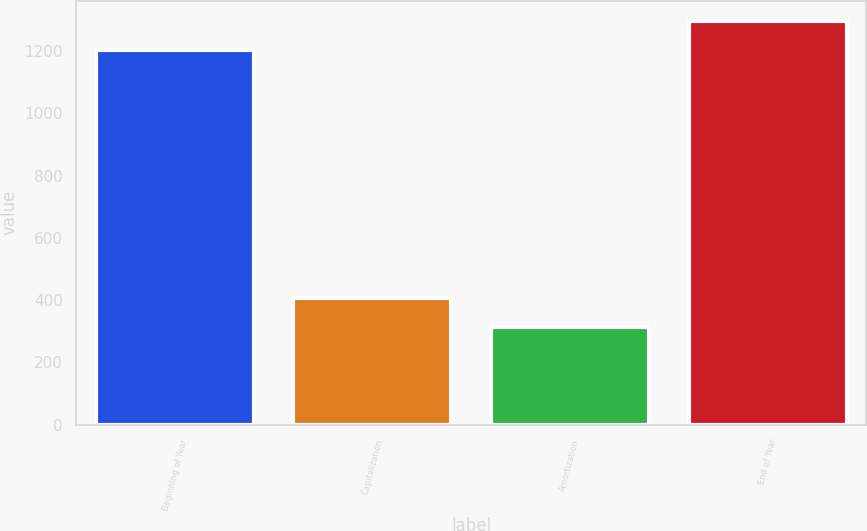Convert chart to OTSL. <chart><loc_0><loc_0><loc_500><loc_500><bar_chart><fcel>Beginning of Year<fcel>Capitalization<fcel>Amortization<fcel>End of Year<nl><fcel>1205.4<fcel>407.53<fcel>315.1<fcel>1297.83<nl></chart> 